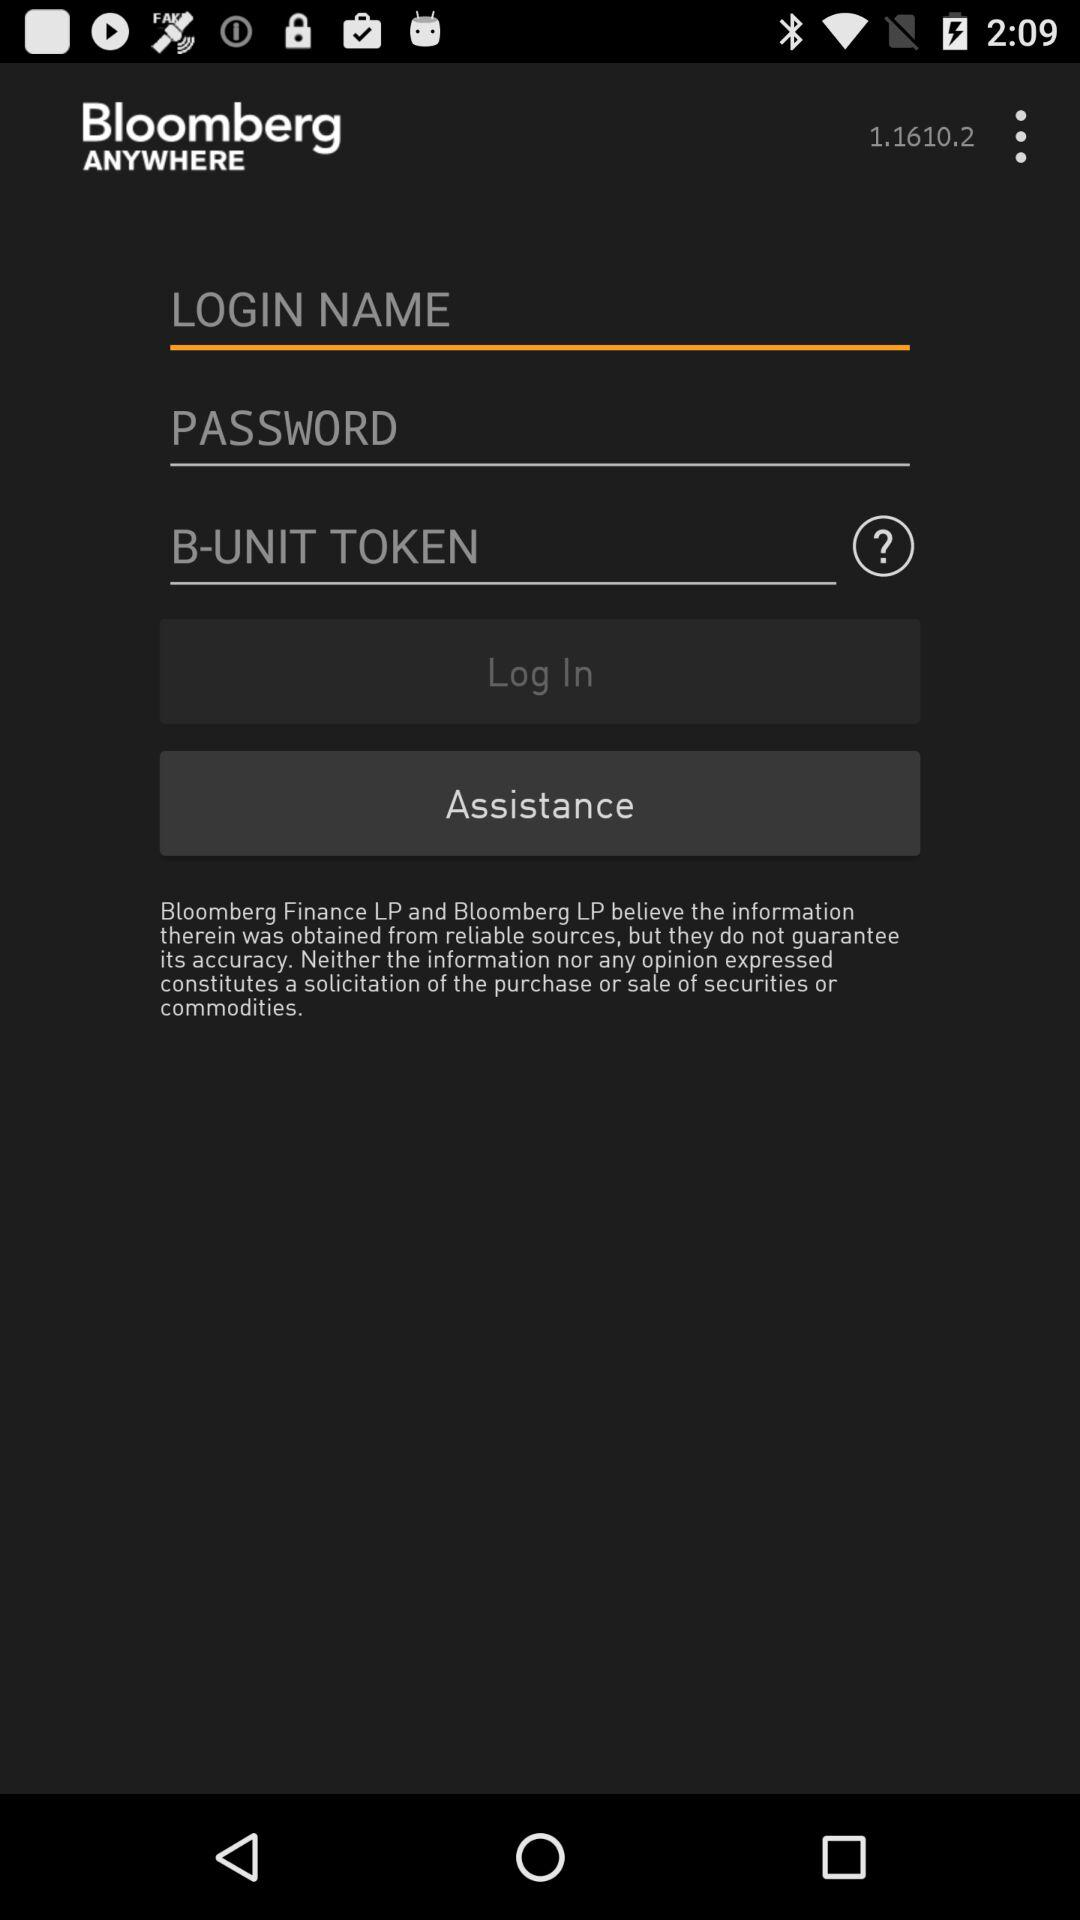What is the name of the application? The application name is "Bloomberg ANYWHERE". 